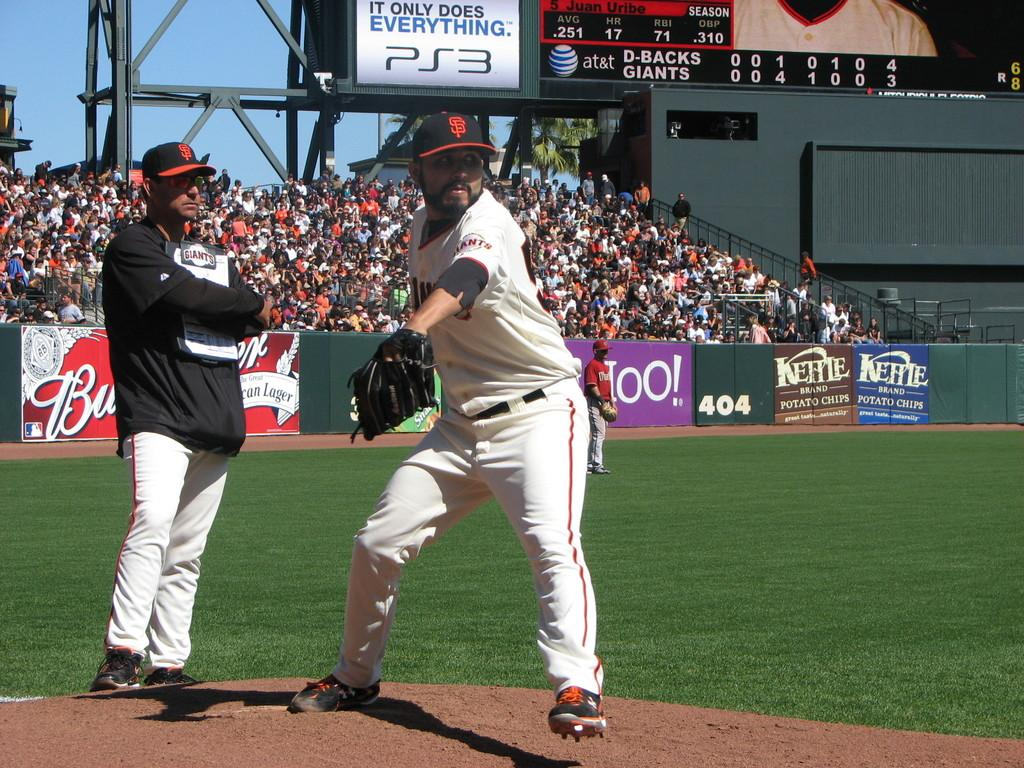<image>
Offer a succinct explanation of the picture presented. A player from the San Francisco Giants is standing on a baseball field. 